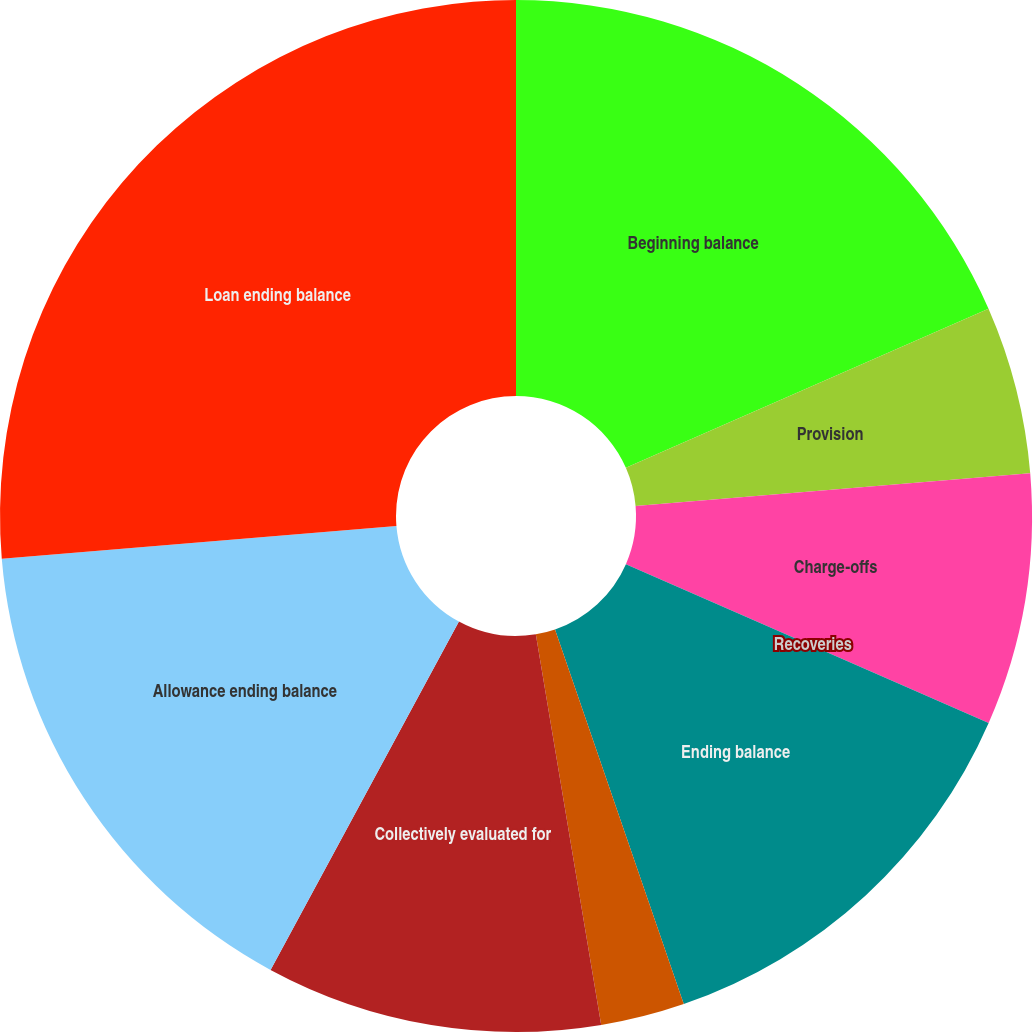Convert chart. <chart><loc_0><loc_0><loc_500><loc_500><pie_chart><fcel>Beginning balance<fcel>Provision<fcel>Charge-offs<fcel>Recoveries<fcel>Ending balance<fcel>Individually evaluated for<fcel>Collectively evaluated for<fcel>Allowance ending balance<fcel>Loan ending balance<nl><fcel>18.42%<fcel>5.26%<fcel>7.89%<fcel>0.0%<fcel>13.16%<fcel>2.63%<fcel>10.53%<fcel>15.79%<fcel>26.32%<nl></chart> 